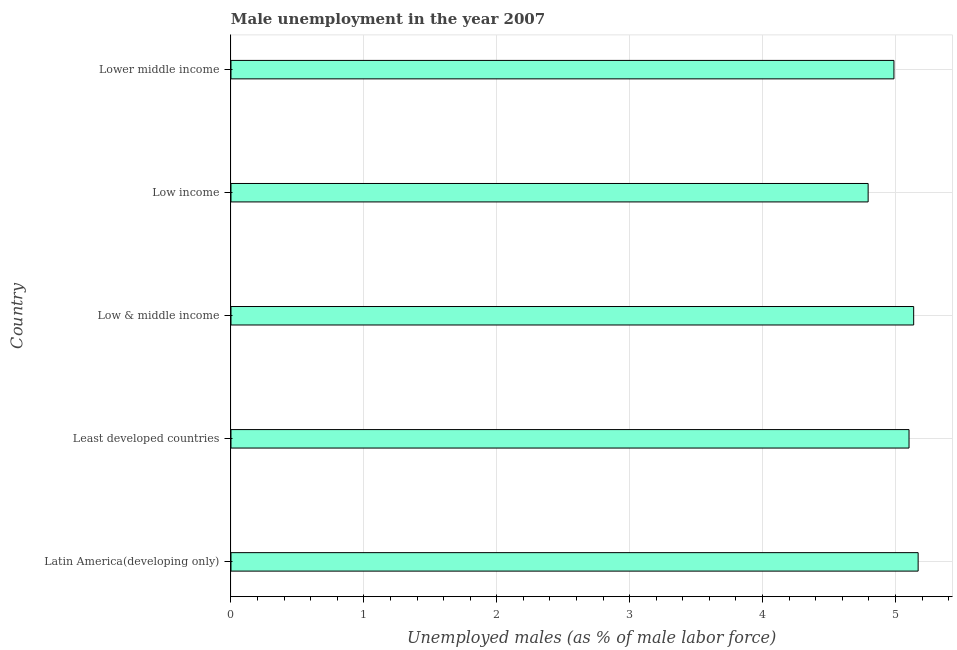What is the title of the graph?
Ensure brevity in your answer.  Male unemployment in the year 2007. What is the label or title of the X-axis?
Offer a very short reply. Unemployed males (as % of male labor force). What is the label or title of the Y-axis?
Provide a short and direct response. Country. What is the unemployed males population in Latin America(developing only)?
Provide a short and direct response. 5.17. Across all countries, what is the maximum unemployed males population?
Make the answer very short. 5.17. Across all countries, what is the minimum unemployed males population?
Offer a terse response. 4.79. In which country was the unemployed males population maximum?
Ensure brevity in your answer.  Latin America(developing only). In which country was the unemployed males population minimum?
Give a very brief answer. Low income. What is the sum of the unemployed males population?
Provide a short and direct response. 25.19. What is the difference between the unemployed males population in Low & middle income and Lower middle income?
Keep it short and to the point. 0.15. What is the average unemployed males population per country?
Your answer should be very brief. 5.04. What is the median unemployed males population?
Your answer should be compact. 5.1. What is the difference between the highest and the second highest unemployed males population?
Offer a terse response. 0.03. What is the difference between the highest and the lowest unemployed males population?
Make the answer very short. 0.38. How many bars are there?
Provide a short and direct response. 5. Are all the bars in the graph horizontal?
Provide a succinct answer. Yes. What is the difference between two consecutive major ticks on the X-axis?
Your answer should be very brief. 1. What is the Unemployed males (as % of male labor force) in Latin America(developing only)?
Give a very brief answer. 5.17. What is the Unemployed males (as % of male labor force) of Least developed countries?
Ensure brevity in your answer.  5.1. What is the Unemployed males (as % of male labor force) of Low & middle income?
Provide a succinct answer. 5.14. What is the Unemployed males (as % of male labor force) of Low income?
Your answer should be compact. 4.79. What is the Unemployed males (as % of male labor force) of Lower middle income?
Your answer should be very brief. 4.99. What is the difference between the Unemployed males (as % of male labor force) in Latin America(developing only) and Least developed countries?
Give a very brief answer. 0.07. What is the difference between the Unemployed males (as % of male labor force) in Latin America(developing only) and Low & middle income?
Offer a very short reply. 0.03. What is the difference between the Unemployed males (as % of male labor force) in Latin America(developing only) and Low income?
Make the answer very short. 0.38. What is the difference between the Unemployed males (as % of male labor force) in Latin America(developing only) and Lower middle income?
Ensure brevity in your answer.  0.18. What is the difference between the Unemployed males (as % of male labor force) in Least developed countries and Low & middle income?
Your answer should be very brief. -0.04. What is the difference between the Unemployed males (as % of male labor force) in Least developed countries and Low income?
Offer a terse response. 0.31. What is the difference between the Unemployed males (as % of male labor force) in Least developed countries and Lower middle income?
Provide a short and direct response. 0.11. What is the difference between the Unemployed males (as % of male labor force) in Low & middle income and Low income?
Give a very brief answer. 0.34. What is the difference between the Unemployed males (as % of male labor force) in Low & middle income and Lower middle income?
Make the answer very short. 0.15. What is the difference between the Unemployed males (as % of male labor force) in Low income and Lower middle income?
Provide a succinct answer. -0.19. What is the ratio of the Unemployed males (as % of male labor force) in Latin America(developing only) to that in Least developed countries?
Provide a short and direct response. 1.01. What is the ratio of the Unemployed males (as % of male labor force) in Latin America(developing only) to that in Low income?
Keep it short and to the point. 1.08. What is the ratio of the Unemployed males (as % of male labor force) in Latin America(developing only) to that in Lower middle income?
Give a very brief answer. 1.04. What is the ratio of the Unemployed males (as % of male labor force) in Least developed countries to that in Low income?
Your answer should be compact. 1.06. What is the ratio of the Unemployed males (as % of male labor force) in Low & middle income to that in Low income?
Provide a short and direct response. 1.07. What is the ratio of the Unemployed males (as % of male labor force) in Low & middle income to that in Lower middle income?
Offer a terse response. 1.03. What is the ratio of the Unemployed males (as % of male labor force) in Low income to that in Lower middle income?
Make the answer very short. 0.96. 